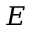Convert formula to latex. <formula><loc_0><loc_0><loc_500><loc_500>E</formula> 